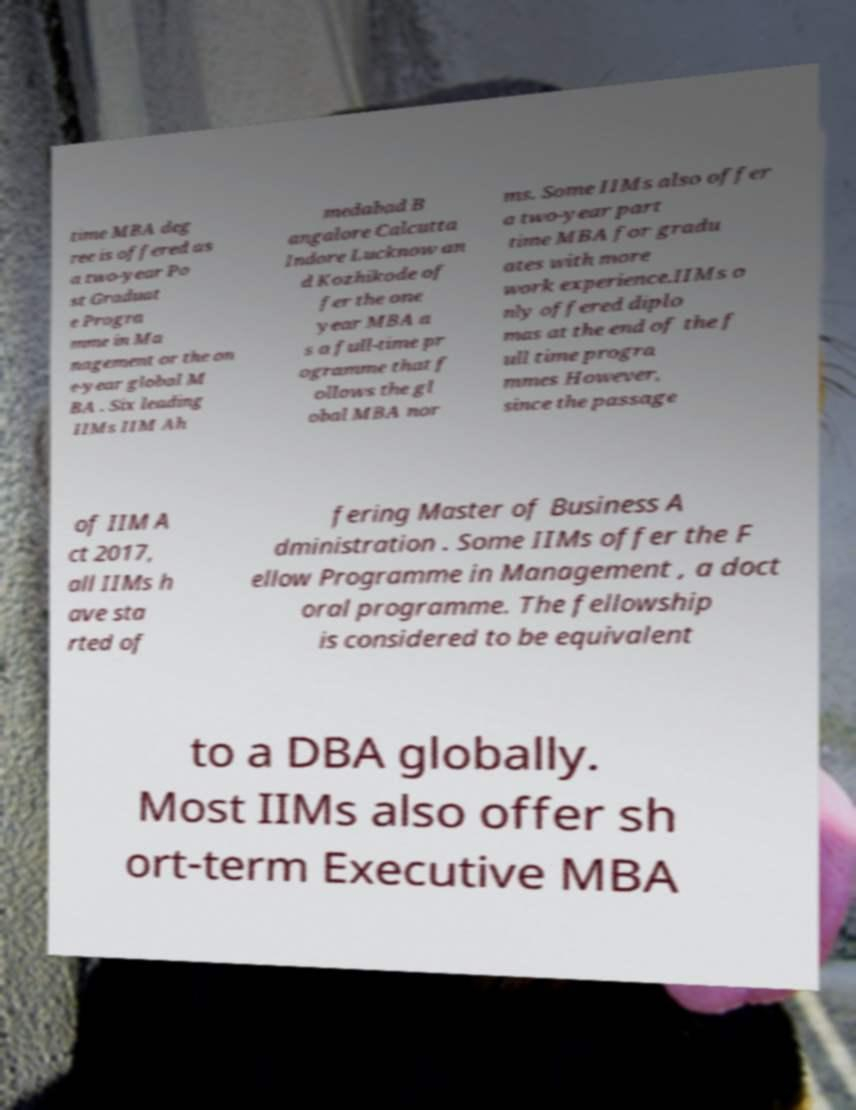Can you accurately transcribe the text from the provided image for me? time MBA deg ree is offered as a two-year Po st Graduat e Progra mme in Ma nagement or the on e-year global M BA . Six leading IIMs IIM Ah medabad B angalore Calcutta Indore Lucknow an d Kozhikode of fer the one year MBA a s a full-time pr ogramme that f ollows the gl obal MBA nor ms. Some IIMs also offer a two-year part time MBA for gradu ates with more work experience.IIMs o nly offered diplo mas at the end of the f ull time progra mmes However, since the passage of IIM A ct 2017, all IIMs h ave sta rted of fering Master of Business A dministration . Some IIMs offer the F ellow Programme in Management , a doct oral programme. The fellowship is considered to be equivalent to a DBA globally. Most IIMs also offer sh ort-term Executive MBA 